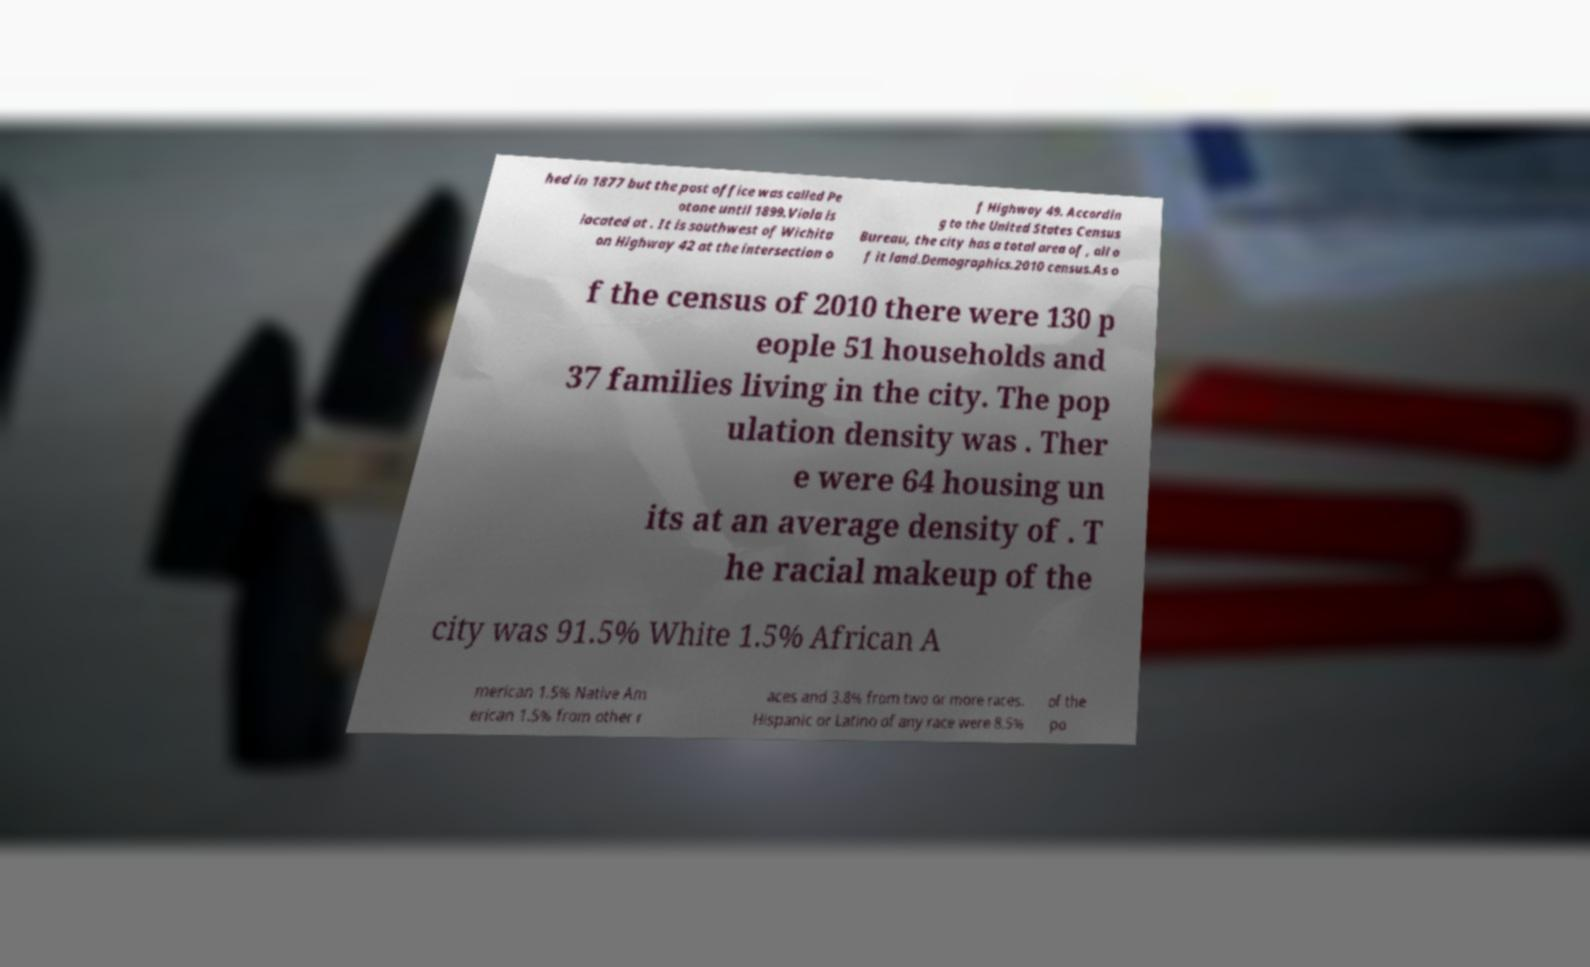Please identify and transcribe the text found in this image. hed in 1877 but the post office was called Pe otone until 1899.Viola is located at . It is southwest of Wichita on Highway 42 at the intersection o f Highway 49. Accordin g to the United States Census Bureau, the city has a total area of , all o f it land.Demographics.2010 census.As o f the census of 2010 there were 130 p eople 51 households and 37 families living in the city. The pop ulation density was . Ther e were 64 housing un its at an average density of . T he racial makeup of the city was 91.5% White 1.5% African A merican 1.5% Native Am erican 1.5% from other r aces and 3.8% from two or more races. Hispanic or Latino of any race were 8.5% of the po 